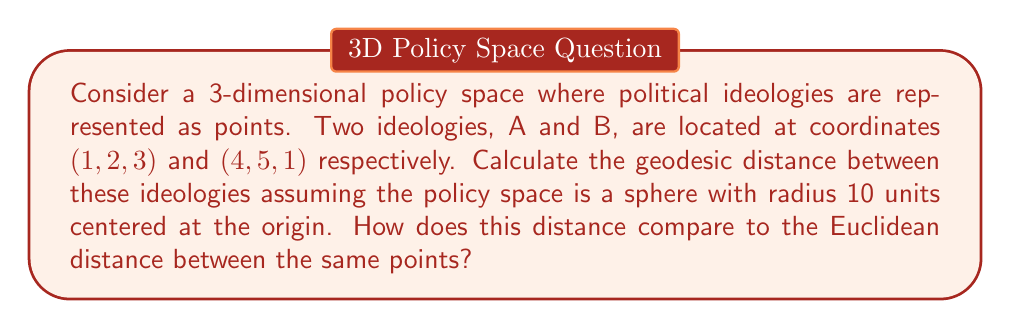Show me your answer to this math problem. 1. First, let's calculate the Euclidean distance between A(1, 2, 3) and B(4, 5, 1):

   $$d_E = \sqrt{(x_2-x_1)^2 + (y_2-y_1)^2 + (z_2-z_1)^2}$$
   $$d_E = \sqrt{(4-1)^2 + (5-2)^2 + (1-3)^2} = \sqrt{9 + 9 + 4} = \sqrt{22} \approx 4.69$$

2. To calculate the geodesic distance on a sphere, we need to convert the Cartesian coordinates to spherical coordinates (latitude and longitude).

3. Convert to spherical coordinates:
   For A(1, 2, 3):
   $$r_A = \sqrt{1^2 + 2^2 + 3^2} = \sqrt{14}$$
   $$\theta_A = \arccos\left(\frac{3}{\sqrt{14}}\right)$$
   $$\phi_A = \arctan\left(\frac{2}{1}\right)$$

   For B(4, 5, 1):
   $$r_B = \sqrt{4^2 + 5^2 + 1^2} = \sqrt{42}$$
   $$\theta_B = \arccos\left(\frac{1}{\sqrt{42}}\right)$$
   $$\phi_B = \arctan\left(\frac{5}{4}\right)$$

4. Project these points onto the sphere with radius 10:
   A': $(\theta_A, \phi_A)$
   B': $(\theta_B, \phi_B)$

5. Calculate the central angle $\Delta\sigma$ between A' and B':
   $$\cos(\Delta\sigma) = \sin\theta_A \sin\theta_B \cos(\phi_B - \phi_A) + \cos\theta_A \cos\theta_B$$

6. The geodesic distance is then:
   $$d_G = R \cdot \arccos(\cos(\Delta\sigma))$$
   where $R = 10$ is the radius of the sphere.

7. Compare the geodesic distance to the Euclidean distance:
   $$\text{Ratio} = \frac{d_G}{d_E}$$
Answer: $d_G = 10 \cdot \arccos(\cos(\Delta\sigma))$, where $\Delta\sigma$ is calculated as in step 5. The ratio of geodesic to Euclidean distance is $\frac{d_G}{d_E}$. 